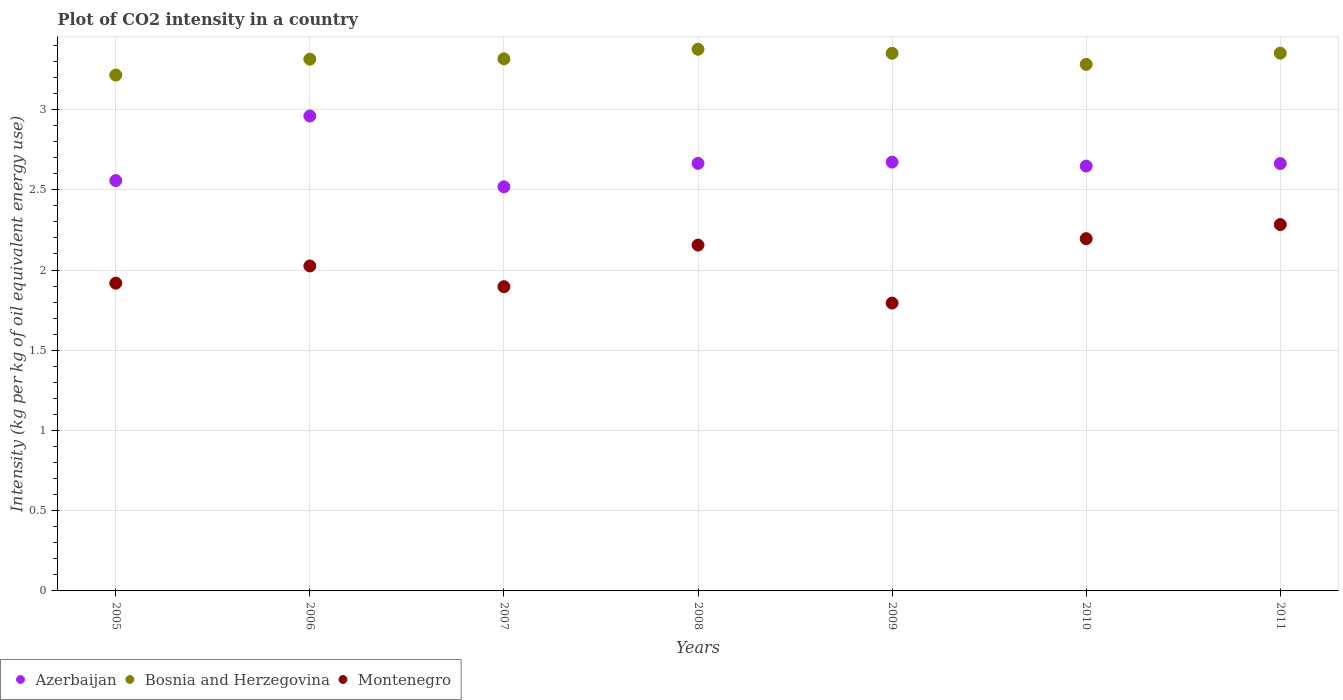Is the number of dotlines equal to the number of legend labels?
Provide a succinct answer. Yes. What is the CO2 intensity in in Montenegro in 2010?
Give a very brief answer. 2.2. Across all years, what is the maximum CO2 intensity in in Bosnia and Herzegovina?
Offer a terse response. 3.38. Across all years, what is the minimum CO2 intensity in in Montenegro?
Make the answer very short. 1.79. What is the total CO2 intensity in in Montenegro in the graph?
Provide a succinct answer. 14.27. What is the difference between the CO2 intensity in in Montenegro in 2006 and that in 2009?
Keep it short and to the point. 0.23. What is the difference between the CO2 intensity in in Bosnia and Herzegovina in 2006 and the CO2 intensity in in Montenegro in 2011?
Your answer should be very brief. 1.03. What is the average CO2 intensity in in Azerbaijan per year?
Keep it short and to the point. 2.67. In the year 2005, what is the difference between the CO2 intensity in in Azerbaijan and CO2 intensity in in Bosnia and Herzegovina?
Provide a succinct answer. -0.66. In how many years, is the CO2 intensity in in Montenegro greater than 2.2 kg?
Offer a very short reply. 1. What is the ratio of the CO2 intensity in in Montenegro in 2005 to that in 2007?
Keep it short and to the point. 1.01. What is the difference between the highest and the second highest CO2 intensity in in Montenegro?
Offer a terse response. 0.09. What is the difference between the highest and the lowest CO2 intensity in in Azerbaijan?
Your answer should be compact. 0.44. In how many years, is the CO2 intensity in in Montenegro greater than the average CO2 intensity in in Montenegro taken over all years?
Give a very brief answer. 3. Is it the case that in every year, the sum of the CO2 intensity in in Montenegro and CO2 intensity in in Azerbaijan  is greater than the CO2 intensity in in Bosnia and Herzegovina?
Offer a very short reply. Yes. Does the CO2 intensity in in Azerbaijan monotonically increase over the years?
Ensure brevity in your answer.  No. Does the graph contain grids?
Your answer should be compact. Yes. How many legend labels are there?
Make the answer very short. 3. What is the title of the graph?
Your answer should be very brief. Plot of CO2 intensity in a country. Does "Iceland" appear as one of the legend labels in the graph?
Your response must be concise. No. What is the label or title of the X-axis?
Offer a very short reply. Years. What is the label or title of the Y-axis?
Offer a terse response. Intensity (kg per kg of oil equivalent energy use). What is the Intensity (kg per kg of oil equivalent energy use) in Azerbaijan in 2005?
Your response must be concise. 2.56. What is the Intensity (kg per kg of oil equivalent energy use) of Bosnia and Herzegovina in 2005?
Offer a terse response. 3.22. What is the Intensity (kg per kg of oil equivalent energy use) in Montenegro in 2005?
Keep it short and to the point. 1.92. What is the Intensity (kg per kg of oil equivalent energy use) of Azerbaijan in 2006?
Your response must be concise. 2.96. What is the Intensity (kg per kg of oil equivalent energy use) in Bosnia and Herzegovina in 2006?
Offer a very short reply. 3.31. What is the Intensity (kg per kg of oil equivalent energy use) of Montenegro in 2006?
Your answer should be compact. 2.03. What is the Intensity (kg per kg of oil equivalent energy use) of Azerbaijan in 2007?
Your answer should be very brief. 2.52. What is the Intensity (kg per kg of oil equivalent energy use) of Bosnia and Herzegovina in 2007?
Give a very brief answer. 3.32. What is the Intensity (kg per kg of oil equivalent energy use) in Montenegro in 2007?
Provide a short and direct response. 1.9. What is the Intensity (kg per kg of oil equivalent energy use) in Azerbaijan in 2008?
Your response must be concise. 2.66. What is the Intensity (kg per kg of oil equivalent energy use) in Bosnia and Herzegovina in 2008?
Keep it short and to the point. 3.38. What is the Intensity (kg per kg of oil equivalent energy use) in Montenegro in 2008?
Ensure brevity in your answer.  2.16. What is the Intensity (kg per kg of oil equivalent energy use) of Azerbaijan in 2009?
Offer a very short reply. 2.67. What is the Intensity (kg per kg of oil equivalent energy use) of Bosnia and Herzegovina in 2009?
Provide a succinct answer. 3.35. What is the Intensity (kg per kg of oil equivalent energy use) in Montenegro in 2009?
Provide a succinct answer. 1.79. What is the Intensity (kg per kg of oil equivalent energy use) of Azerbaijan in 2010?
Offer a very short reply. 2.65. What is the Intensity (kg per kg of oil equivalent energy use) in Bosnia and Herzegovina in 2010?
Your response must be concise. 3.28. What is the Intensity (kg per kg of oil equivalent energy use) of Montenegro in 2010?
Give a very brief answer. 2.2. What is the Intensity (kg per kg of oil equivalent energy use) in Azerbaijan in 2011?
Ensure brevity in your answer.  2.66. What is the Intensity (kg per kg of oil equivalent energy use) of Bosnia and Herzegovina in 2011?
Provide a succinct answer. 3.35. What is the Intensity (kg per kg of oil equivalent energy use) in Montenegro in 2011?
Provide a succinct answer. 2.28. Across all years, what is the maximum Intensity (kg per kg of oil equivalent energy use) of Azerbaijan?
Your response must be concise. 2.96. Across all years, what is the maximum Intensity (kg per kg of oil equivalent energy use) in Bosnia and Herzegovina?
Offer a terse response. 3.38. Across all years, what is the maximum Intensity (kg per kg of oil equivalent energy use) in Montenegro?
Your response must be concise. 2.28. Across all years, what is the minimum Intensity (kg per kg of oil equivalent energy use) of Azerbaijan?
Give a very brief answer. 2.52. Across all years, what is the minimum Intensity (kg per kg of oil equivalent energy use) of Bosnia and Herzegovina?
Ensure brevity in your answer.  3.22. Across all years, what is the minimum Intensity (kg per kg of oil equivalent energy use) of Montenegro?
Ensure brevity in your answer.  1.79. What is the total Intensity (kg per kg of oil equivalent energy use) in Azerbaijan in the graph?
Provide a short and direct response. 18.69. What is the total Intensity (kg per kg of oil equivalent energy use) in Bosnia and Herzegovina in the graph?
Keep it short and to the point. 23.21. What is the total Intensity (kg per kg of oil equivalent energy use) in Montenegro in the graph?
Offer a very short reply. 14.27. What is the difference between the Intensity (kg per kg of oil equivalent energy use) of Azerbaijan in 2005 and that in 2006?
Ensure brevity in your answer.  -0.4. What is the difference between the Intensity (kg per kg of oil equivalent energy use) in Bosnia and Herzegovina in 2005 and that in 2006?
Provide a short and direct response. -0.1. What is the difference between the Intensity (kg per kg of oil equivalent energy use) in Montenegro in 2005 and that in 2006?
Make the answer very short. -0.11. What is the difference between the Intensity (kg per kg of oil equivalent energy use) of Azerbaijan in 2005 and that in 2007?
Your answer should be compact. 0.04. What is the difference between the Intensity (kg per kg of oil equivalent energy use) of Bosnia and Herzegovina in 2005 and that in 2007?
Provide a succinct answer. -0.1. What is the difference between the Intensity (kg per kg of oil equivalent energy use) in Montenegro in 2005 and that in 2007?
Offer a very short reply. 0.02. What is the difference between the Intensity (kg per kg of oil equivalent energy use) of Azerbaijan in 2005 and that in 2008?
Your response must be concise. -0.11. What is the difference between the Intensity (kg per kg of oil equivalent energy use) of Bosnia and Herzegovina in 2005 and that in 2008?
Keep it short and to the point. -0.16. What is the difference between the Intensity (kg per kg of oil equivalent energy use) of Montenegro in 2005 and that in 2008?
Offer a very short reply. -0.24. What is the difference between the Intensity (kg per kg of oil equivalent energy use) in Azerbaijan in 2005 and that in 2009?
Provide a succinct answer. -0.12. What is the difference between the Intensity (kg per kg of oil equivalent energy use) of Bosnia and Herzegovina in 2005 and that in 2009?
Offer a very short reply. -0.14. What is the difference between the Intensity (kg per kg of oil equivalent energy use) in Montenegro in 2005 and that in 2009?
Ensure brevity in your answer.  0.12. What is the difference between the Intensity (kg per kg of oil equivalent energy use) of Azerbaijan in 2005 and that in 2010?
Ensure brevity in your answer.  -0.09. What is the difference between the Intensity (kg per kg of oil equivalent energy use) of Bosnia and Herzegovina in 2005 and that in 2010?
Offer a very short reply. -0.07. What is the difference between the Intensity (kg per kg of oil equivalent energy use) of Montenegro in 2005 and that in 2010?
Give a very brief answer. -0.28. What is the difference between the Intensity (kg per kg of oil equivalent energy use) of Azerbaijan in 2005 and that in 2011?
Keep it short and to the point. -0.11. What is the difference between the Intensity (kg per kg of oil equivalent energy use) of Bosnia and Herzegovina in 2005 and that in 2011?
Keep it short and to the point. -0.14. What is the difference between the Intensity (kg per kg of oil equivalent energy use) in Montenegro in 2005 and that in 2011?
Provide a short and direct response. -0.37. What is the difference between the Intensity (kg per kg of oil equivalent energy use) in Azerbaijan in 2006 and that in 2007?
Ensure brevity in your answer.  0.44. What is the difference between the Intensity (kg per kg of oil equivalent energy use) in Bosnia and Herzegovina in 2006 and that in 2007?
Provide a short and direct response. -0. What is the difference between the Intensity (kg per kg of oil equivalent energy use) in Montenegro in 2006 and that in 2007?
Your answer should be compact. 0.13. What is the difference between the Intensity (kg per kg of oil equivalent energy use) in Azerbaijan in 2006 and that in 2008?
Your response must be concise. 0.3. What is the difference between the Intensity (kg per kg of oil equivalent energy use) of Bosnia and Herzegovina in 2006 and that in 2008?
Your answer should be very brief. -0.06. What is the difference between the Intensity (kg per kg of oil equivalent energy use) of Montenegro in 2006 and that in 2008?
Your answer should be very brief. -0.13. What is the difference between the Intensity (kg per kg of oil equivalent energy use) in Azerbaijan in 2006 and that in 2009?
Your answer should be compact. 0.29. What is the difference between the Intensity (kg per kg of oil equivalent energy use) in Bosnia and Herzegovina in 2006 and that in 2009?
Offer a very short reply. -0.04. What is the difference between the Intensity (kg per kg of oil equivalent energy use) of Montenegro in 2006 and that in 2009?
Give a very brief answer. 0.23. What is the difference between the Intensity (kg per kg of oil equivalent energy use) in Azerbaijan in 2006 and that in 2010?
Keep it short and to the point. 0.31. What is the difference between the Intensity (kg per kg of oil equivalent energy use) in Bosnia and Herzegovina in 2006 and that in 2010?
Make the answer very short. 0.03. What is the difference between the Intensity (kg per kg of oil equivalent energy use) of Montenegro in 2006 and that in 2010?
Provide a succinct answer. -0.17. What is the difference between the Intensity (kg per kg of oil equivalent energy use) of Azerbaijan in 2006 and that in 2011?
Your answer should be very brief. 0.3. What is the difference between the Intensity (kg per kg of oil equivalent energy use) of Bosnia and Herzegovina in 2006 and that in 2011?
Give a very brief answer. -0.04. What is the difference between the Intensity (kg per kg of oil equivalent energy use) of Montenegro in 2006 and that in 2011?
Make the answer very short. -0.26. What is the difference between the Intensity (kg per kg of oil equivalent energy use) of Azerbaijan in 2007 and that in 2008?
Your response must be concise. -0.15. What is the difference between the Intensity (kg per kg of oil equivalent energy use) of Bosnia and Herzegovina in 2007 and that in 2008?
Offer a very short reply. -0.06. What is the difference between the Intensity (kg per kg of oil equivalent energy use) of Montenegro in 2007 and that in 2008?
Your response must be concise. -0.26. What is the difference between the Intensity (kg per kg of oil equivalent energy use) of Azerbaijan in 2007 and that in 2009?
Offer a terse response. -0.15. What is the difference between the Intensity (kg per kg of oil equivalent energy use) in Bosnia and Herzegovina in 2007 and that in 2009?
Provide a short and direct response. -0.03. What is the difference between the Intensity (kg per kg of oil equivalent energy use) of Montenegro in 2007 and that in 2009?
Provide a succinct answer. 0.1. What is the difference between the Intensity (kg per kg of oil equivalent energy use) in Azerbaijan in 2007 and that in 2010?
Offer a terse response. -0.13. What is the difference between the Intensity (kg per kg of oil equivalent energy use) in Bosnia and Herzegovina in 2007 and that in 2010?
Your answer should be compact. 0.03. What is the difference between the Intensity (kg per kg of oil equivalent energy use) in Montenegro in 2007 and that in 2010?
Provide a succinct answer. -0.3. What is the difference between the Intensity (kg per kg of oil equivalent energy use) in Azerbaijan in 2007 and that in 2011?
Make the answer very short. -0.14. What is the difference between the Intensity (kg per kg of oil equivalent energy use) in Bosnia and Herzegovina in 2007 and that in 2011?
Ensure brevity in your answer.  -0.04. What is the difference between the Intensity (kg per kg of oil equivalent energy use) of Montenegro in 2007 and that in 2011?
Offer a very short reply. -0.39. What is the difference between the Intensity (kg per kg of oil equivalent energy use) in Azerbaijan in 2008 and that in 2009?
Offer a terse response. -0.01. What is the difference between the Intensity (kg per kg of oil equivalent energy use) of Bosnia and Herzegovina in 2008 and that in 2009?
Keep it short and to the point. 0.03. What is the difference between the Intensity (kg per kg of oil equivalent energy use) in Montenegro in 2008 and that in 2009?
Provide a succinct answer. 0.36. What is the difference between the Intensity (kg per kg of oil equivalent energy use) of Azerbaijan in 2008 and that in 2010?
Provide a short and direct response. 0.02. What is the difference between the Intensity (kg per kg of oil equivalent energy use) in Bosnia and Herzegovina in 2008 and that in 2010?
Keep it short and to the point. 0.09. What is the difference between the Intensity (kg per kg of oil equivalent energy use) in Montenegro in 2008 and that in 2010?
Your response must be concise. -0.04. What is the difference between the Intensity (kg per kg of oil equivalent energy use) in Azerbaijan in 2008 and that in 2011?
Provide a succinct answer. 0. What is the difference between the Intensity (kg per kg of oil equivalent energy use) in Bosnia and Herzegovina in 2008 and that in 2011?
Provide a short and direct response. 0.02. What is the difference between the Intensity (kg per kg of oil equivalent energy use) of Montenegro in 2008 and that in 2011?
Your answer should be compact. -0.13. What is the difference between the Intensity (kg per kg of oil equivalent energy use) of Azerbaijan in 2009 and that in 2010?
Offer a very short reply. 0.02. What is the difference between the Intensity (kg per kg of oil equivalent energy use) in Bosnia and Herzegovina in 2009 and that in 2010?
Keep it short and to the point. 0.07. What is the difference between the Intensity (kg per kg of oil equivalent energy use) of Montenegro in 2009 and that in 2010?
Your answer should be very brief. -0.4. What is the difference between the Intensity (kg per kg of oil equivalent energy use) in Azerbaijan in 2009 and that in 2011?
Your response must be concise. 0.01. What is the difference between the Intensity (kg per kg of oil equivalent energy use) of Bosnia and Herzegovina in 2009 and that in 2011?
Provide a short and direct response. -0. What is the difference between the Intensity (kg per kg of oil equivalent energy use) of Montenegro in 2009 and that in 2011?
Your answer should be very brief. -0.49. What is the difference between the Intensity (kg per kg of oil equivalent energy use) of Azerbaijan in 2010 and that in 2011?
Your answer should be very brief. -0.02. What is the difference between the Intensity (kg per kg of oil equivalent energy use) in Bosnia and Herzegovina in 2010 and that in 2011?
Keep it short and to the point. -0.07. What is the difference between the Intensity (kg per kg of oil equivalent energy use) of Montenegro in 2010 and that in 2011?
Keep it short and to the point. -0.09. What is the difference between the Intensity (kg per kg of oil equivalent energy use) in Azerbaijan in 2005 and the Intensity (kg per kg of oil equivalent energy use) in Bosnia and Herzegovina in 2006?
Provide a succinct answer. -0.76. What is the difference between the Intensity (kg per kg of oil equivalent energy use) of Azerbaijan in 2005 and the Intensity (kg per kg of oil equivalent energy use) of Montenegro in 2006?
Make the answer very short. 0.53. What is the difference between the Intensity (kg per kg of oil equivalent energy use) of Bosnia and Herzegovina in 2005 and the Intensity (kg per kg of oil equivalent energy use) of Montenegro in 2006?
Provide a short and direct response. 1.19. What is the difference between the Intensity (kg per kg of oil equivalent energy use) in Azerbaijan in 2005 and the Intensity (kg per kg of oil equivalent energy use) in Bosnia and Herzegovina in 2007?
Make the answer very short. -0.76. What is the difference between the Intensity (kg per kg of oil equivalent energy use) in Azerbaijan in 2005 and the Intensity (kg per kg of oil equivalent energy use) in Montenegro in 2007?
Your response must be concise. 0.66. What is the difference between the Intensity (kg per kg of oil equivalent energy use) in Bosnia and Herzegovina in 2005 and the Intensity (kg per kg of oil equivalent energy use) in Montenegro in 2007?
Provide a short and direct response. 1.32. What is the difference between the Intensity (kg per kg of oil equivalent energy use) of Azerbaijan in 2005 and the Intensity (kg per kg of oil equivalent energy use) of Bosnia and Herzegovina in 2008?
Provide a short and direct response. -0.82. What is the difference between the Intensity (kg per kg of oil equivalent energy use) in Azerbaijan in 2005 and the Intensity (kg per kg of oil equivalent energy use) in Montenegro in 2008?
Give a very brief answer. 0.4. What is the difference between the Intensity (kg per kg of oil equivalent energy use) in Bosnia and Herzegovina in 2005 and the Intensity (kg per kg of oil equivalent energy use) in Montenegro in 2008?
Make the answer very short. 1.06. What is the difference between the Intensity (kg per kg of oil equivalent energy use) in Azerbaijan in 2005 and the Intensity (kg per kg of oil equivalent energy use) in Bosnia and Herzegovina in 2009?
Your answer should be compact. -0.79. What is the difference between the Intensity (kg per kg of oil equivalent energy use) of Azerbaijan in 2005 and the Intensity (kg per kg of oil equivalent energy use) of Montenegro in 2009?
Give a very brief answer. 0.76. What is the difference between the Intensity (kg per kg of oil equivalent energy use) in Bosnia and Herzegovina in 2005 and the Intensity (kg per kg of oil equivalent energy use) in Montenegro in 2009?
Provide a short and direct response. 1.42. What is the difference between the Intensity (kg per kg of oil equivalent energy use) in Azerbaijan in 2005 and the Intensity (kg per kg of oil equivalent energy use) in Bosnia and Herzegovina in 2010?
Provide a succinct answer. -0.72. What is the difference between the Intensity (kg per kg of oil equivalent energy use) in Azerbaijan in 2005 and the Intensity (kg per kg of oil equivalent energy use) in Montenegro in 2010?
Your answer should be very brief. 0.36. What is the difference between the Intensity (kg per kg of oil equivalent energy use) of Bosnia and Herzegovina in 2005 and the Intensity (kg per kg of oil equivalent energy use) of Montenegro in 2010?
Ensure brevity in your answer.  1.02. What is the difference between the Intensity (kg per kg of oil equivalent energy use) of Azerbaijan in 2005 and the Intensity (kg per kg of oil equivalent energy use) of Bosnia and Herzegovina in 2011?
Your response must be concise. -0.79. What is the difference between the Intensity (kg per kg of oil equivalent energy use) of Azerbaijan in 2005 and the Intensity (kg per kg of oil equivalent energy use) of Montenegro in 2011?
Make the answer very short. 0.27. What is the difference between the Intensity (kg per kg of oil equivalent energy use) in Bosnia and Herzegovina in 2005 and the Intensity (kg per kg of oil equivalent energy use) in Montenegro in 2011?
Your response must be concise. 0.93. What is the difference between the Intensity (kg per kg of oil equivalent energy use) in Azerbaijan in 2006 and the Intensity (kg per kg of oil equivalent energy use) in Bosnia and Herzegovina in 2007?
Ensure brevity in your answer.  -0.36. What is the difference between the Intensity (kg per kg of oil equivalent energy use) of Azerbaijan in 2006 and the Intensity (kg per kg of oil equivalent energy use) of Montenegro in 2007?
Ensure brevity in your answer.  1.06. What is the difference between the Intensity (kg per kg of oil equivalent energy use) in Bosnia and Herzegovina in 2006 and the Intensity (kg per kg of oil equivalent energy use) in Montenegro in 2007?
Keep it short and to the point. 1.42. What is the difference between the Intensity (kg per kg of oil equivalent energy use) in Azerbaijan in 2006 and the Intensity (kg per kg of oil equivalent energy use) in Bosnia and Herzegovina in 2008?
Your answer should be very brief. -0.42. What is the difference between the Intensity (kg per kg of oil equivalent energy use) of Azerbaijan in 2006 and the Intensity (kg per kg of oil equivalent energy use) of Montenegro in 2008?
Give a very brief answer. 0.8. What is the difference between the Intensity (kg per kg of oil equivalent energy use) in Bosnia and Herzegovina in 2006 and the Intensity (kg per kg of oil equivalent energy use) in Montenegro in 2008?
Your answer should be compact. 1.16. What is the difference between the Intensity (kg per kg of oil equivalent energy use) in Azerbaijan in 2006 and the Intensity (kg per kg of oil equivalent energy use) in Bosnia and Herzegovina in 2009?
Your answer should be compact. -0.39. What is the difference between the Intensity (kg per kg of oil equivalent energy use) in Azerbaijan in 2006 and the Intensity (kg per kg of oil equivalent energy use) in Montenegro in 2009?
Offer a very short reply. 1.17. What is the difference between the Intensity (kg per kg of oil equivalent energy use) in Bosnia and Herzegovina in 2006 and the Intensity (kg per kg of oil equivalent energy use) in Montenegro in 2009?
Your answer should be very brief. 1.52. What is the difference between the Intensity (kg per kg of oil equivalent energy use) of Azerbaijan in 2006 and the Intensity (kg per kg of oil equivalent energy use) of Bosnia and Herzegovina in 2010?
Your response must be concise. -0.32. What is the difference between the Intensity (kg per kg of oil equivalent energy use) in Azerbaijan in 2006 and the Intensity (kg per kg of oil equivalent energy use) in Montenegro in 2010?
Your answer should be very brief. 0.76. What is the difference between the Intensity (kg per kg of oil equivalent energy use) of Bosnia and Herzegovina in 2006 and the Intensity (kg per kg of oil equivalent energy use) of Montenegro in 2010?
Keep it short and to the point. 1.12. What is the difference between the Intensity (kg per kg of oil equivalent energy use) in Azerbaijan in 2006 and the Intensity (kg per kg of oil equivalent energy use) in Bosnia and Herzegovina in 2011?
Give a very brief answer. -0.39. What is the difference between the Intensity (kg per kg of oil equivalent energy use) of Azerbaijan in 2006 and the Intensity (kg per kg of oil equivalent energy use) of Montenegro in 2011?
Give a very brief answer. 0.68. What is the difference between the Intensity (kg per kg of oil equivalent energy use) of Bosnia and Herzegovina in 2006 and the Intensity (kg per kg of oil equivalent energy use) of Montenegro in 2011?
Make the answer very short. 1.03. What is the difference between the Intensity (kg per kg of oil equivalent energy use) in Azerbaijan in 2007 and the Intensity (kg per kg of oil equivalent energy use) in Bosnia and Herzegovina in 2008?
Your answer should be very brief. -0.86. What is the difference between the Intensity (kg per kg of oil equivalent energy use) of Azerbaijan in 2007 and the Intensity (kg per kg of oil equivalent energy use) of Montenegro in 2008?
Your answer should be very brief. 0.36. What is the difference between the Intensity (kg per kg of oil equivalent energy use) in Bosnia and Herzegovina in 2007 and the Intensity (kg per kg of oil equivalent energy use) in Montenegro in 2008?
Your response must be concise. 1.16. What is the difference between the Intensity (kg per kg of oil equivalent energy use) of Azerbaijan in 2007 and the Intensity (kg per kg of oil equivalent energy use) of Bosnia and Herzegovina in 2009?
Offer a terse response. -0.83. What is the difference between the Intensity (kg per kg of oil equivalent energy use) of Azerbaijan in 2007 and the Intensity (kg per kg of oil equivalent energy use) of Montenegro in 2009?
Your response must be concise. 0.72. What is the difference between the Intensity (kg per kg of oil equivalent energy use) of Bosnia and Herzegovina in 2007 and the Intensity (kg per kg of oil equivalent energy use) of Montenegro in 2009?
Ensure brevity in your answer.  1.52. What is the difference between the Intensity (kg per kg of oil equivalent energy use) in Azerbaijan in 2007 and the Intensity (kg per kg of oil equivalent energy use) in Bosnia and Herzegovina in 2010?
Provide a succinct answer. -0.76. What is the difference between the Intensity (kg per kg of oil equivalent energy use) in Azerbaijan in 2007 and the Intensity (kg per kg of oil equivalent energy use) in Montenegro in 2010?
Your answer should be very brief. 0.32. What is the difference between the Intensity (kg per kg of oil equivalent energy use) of Bosnia and Herzegovina in 2007 and the Intensity (kg per kg of oil equivalent energy use) of Montenegro in 2010?
Your answer should be very brief. 1.12. What is the difference between the Intensity (kg per kg of oil equivalent energy use) in Azerbaijan in 2007 and the Intensity (kg per kg of oil equivalent energy use) in Bosnia and Herzegovina in 2011?
Provide a short and direct response. -0.83. What is the difference between the Intensity (kg per kg of oil equivalent energy use) in Azerbaijan in 2007 and the Intensity (kg per kg of oil equivalent energy use) in Montenegro in 2011?
Your response must be concise. 0.24. What is the difference between the Intensity (kg per kg of oil equivalent energy use) in Bosnia and Herzegovina in 2007 and the Intensity (kg per kg of oil equivalent energy use) in Montenegro in 2011?
Offer a terse response. 1.03. What is the difference between the Intensity (kg per kg of oil equivalent energy use) in Azerbaijan in 2008 and the Intensity (kg per kg of oil equivalent energy use) in Bosnia and Herzegovina in 2009?
Your answer should be very brief. -0.69. What is the difference between the Intensity (kg per kg of oil equivalent energy use) in Azerbaijan in 2008 and the Intensity (kg per kg of oil equivalent energy use) in Montenegro in 2009?
Your response must be concise. 0.87. What is the difference between the Intensity (kg per kg of oil equivalent energy use) of Bosnia and Herzegovina in 2008 and the Intensity (kg per kg of oil equivalent energy use) of Montenegro in 2009?
Provide a succinct answer. 1.58. What is the difference between the Intensity (kg per kg of oil equivalent energy use) of Azerbaijan in 2008 and the Intensity (kg per kg of oil equivalent energy use) of Bosnia and Herzegovina in 2010?
Your response must be concise. -0.62. What is the difference between the Intensity (kg per kg of oil equivalent energy use) of Azerbaijan in 2008 and the Intensity (kg per kg of oil equivalent energy use) of Montenegro in 2010?
Provide a short and direct response. 0.47. What is the difference between the Intensity (kg per kg of oil equivalent energy use) in Bosnia and Herzegovina in 2008 and the Intensity (kg per kg of oil equivalent energy use) in Montenegro in 2010?
Provide a short and direct response. 1.18. What is the difference between the Intensity (kg per kg of oil equivalent energy use) of Azerbaijan in 2008 and the Intensity (kg per kg of oil equivalent energy use) of Bosnia and Herzegovina in 2011?
Ensure brevity in your answer.  -0.69. What is the difference between the Intensity (kg per kg of oil equivalent energy use) of Azerbaijan in 2008 and the Intensity (kg per kg of oil equivalent energy use) of Montenegro in 2011?
Provide a short and direct response. 0.38. What is the difference between the Intensity (kg per kg of oil equivalent energy use) of Bosnia and Herzegovina in 2008 and the Intensity (kg per kg of oil equivalent energy use) of Montenegro in 2011?
Keep it short and to the point. 1.09. What is the difference between the Intensity (kg per kg of oil equivalent energy use) of Azerbaijan in 2009 and the Intensity (kg per kg of oil equivalent energy use) of Bosnia and Herzegovina in 2010?
Your answer should be compact. -0.61. What is the difference between the Intensity (kg per kg of oil equivalent energy use) in Azerbaijan in 2009 and the Intensity (kg per kg of oil equivalent energy use) in Montenegro in 2010?
Keep it short and to the point. 0.48. What is the difference between the Intensity (kg per kg of oil equivalent energy use) in Bosnia and Herzegovina in 2009 and the Intensity (kg per kg of oil equivalent energy use) in Montenegro in 2010?
Provide a succinct answer. 1.16. What is the difference between the Intensity (kg per kg of oil equivalent energy use) in Azerbaijan in 2009 and the Intensity (kg per kg of oil equivalent energy use) in Bosnia and Herzegovina in 2011?
Provide a short and direct response. -0.68. What is the difference between the Intensity (kg per kg of oil equivalent energy use) of Azerbaijan in 2009 and the Intensity (kg per kg of oil equivalent energy use) of Montenegro in 2011?
Provide a succinct answer. 0.39. What is the difference between the Intensity (kg per kg of oil equivalent energy use) of Bosnia and Herzegovina in 2009 and the Intensity (kg per kg of oil equivalent energy use) of Montenegro in 2011?
Provide a short and direct response. 1.07. What is the difference between the Intensity (kg per kg of oil equivalent energy use) in Azerbaijan in 2010 and the Intensity (kg per kg of oil equivalent energy use) in Bosnia and Herzegovina in 2011?
Provide a short and direct response. -0.7. What is the difference between the Intensity (kg per kg of oil equivalent energy use) in Azerbaijan in 2010 and the Intensity (kg per kg of oil equivalent energy use) in Montenegro in 2011?
Your answer should be compact. 0.36. What is the average Intensity (kg per kg of oil equivalent energy use) of Azerbaijan per year?
Your answer should be very brief. 2.67. What is the average Intensity (kg per kg of oil equivalent energy use) in Bosnia and Herzegovina per year?
Keep it short and to the point. 3.32. What is the average Intensity (kg per kg of oil equivalent energy use) of Montenegro per year?
Offer a very short reply. 2.04. In the year 2005, what is the difference between the Intensity (kg per kg of oil equivalent energy use) of Azerbaijan and Intensity (kg per kg of oil equivalent energy use) of Bosnia and Herzegovina?
Offer a terse response. -0.66. In the year 2005, what is the difference between the Intensity (kg per kg of oil equivalent energy use) of Azerbaijan and Intensity (kg per kg of oil equivalent energy use) of Montenegro?
Your answer should be very brief. 0.64. In the year 2005, what is the difference between the Intensity (kg per kg of oil equivalent energy use) in Bosnia and Herzegovina and Intensity (kg per kg of oil equivalent energy use) in Montenegro?
Ensure brevity in your answer.  1.3. In the year 2006, what is the difference between the Intensity (kg per kg of oil equivalent energy use) in Azerbaijan and Intensity (kg per kg of oil equivalent energy use) in Bosnia and Herzegovina?
Your answer should be very brief. -0.35. In the year 2006, what is the difference between the Intensity (kg per kg of oil equivalent energy use) of Azerbaijan and Intensity (kg per kg of oil equivalent energy use) of Montenegro?
Give a very brief answer. 0.93. In the year 2006, what is the difference between the Intensity (kg per kg of oil equivalent energy use) of Bosnia and Herzegovina and Intensity (kg per kg of oil equivalent energy use) of Montenegro?
Keep it short and to the point. 1.29. In the year 2007, what is the difference between the Intensity (kg per kg of oil equivalent energy use) of Azerbaijan and Intensity (kg per kg of oil equivalent energy use) of Bosnia and Herzegovina?
Make the answer very short. -0.8. In the year 2007, what is the difference between the Intensity (kg per kg of oil equivalent energy use) of Azerbaijan and Intensity (kg per kg of oil equivalent energy use) of Montenegro?
Ensure brevity in your answer.  0.62. In the year 2007, what is the difference between the Intensity (kg per kg of oil equivalent energy use) of Bosnia and Herzegovina and Intensity (kg per kg of oil equivalent energy use) of Montenegro?
Provide a short and direct response. 1.42. In the year 2008, what is the difference between the Intensity (kg per kg of oil equivalent energy use) in Azerbaijan and Intensity (kg per kg of oil equivalent energy use) in Bosnia and Herzegovina?
Offer a very short reply. -0.71. In the year 2008, what is the difference between the Intensity (kg per kg of oil equivalent energy use) in Azerbaijan and Intensity (kg per kg of oil equivalent energy use) in Montenegro?
Keep it short and to the point. 0.51. In the year 2008, what is the difference between the Intensity (kg per kg of oil equivalent energy use) in Bosnia and Herzegovina and Intensity (kg per kg of oil equivalent energy use) in Montenegro?
Your response must be concise. 1.22. In the year 2009, what is the difference between the Intensity (kg per kg of oil equivalent energy use) of Azerbaijan and Intensity (kg per kg of oil equivalent energy use) of Bosnia and Herzegovina?
Offer a very short reply. -0.68. In the year 2009, what is the difference between the Intensity (kg per kg of oil equivalent energy use) in Azerbaijan and Intensity (kg per kg of oil equivalent energy use) in Montenegro?
Ensure brevity in your answer.  0.88. In the year 2009, what is the difference between the Intensity (kg per kg of oil equivalent energy use) of Bosnia and Herzegovina and Intensity (kg per kg of oil equivalent energy use) of Montenegro?
Give a very brief answer. 1.56. In the year 2010, what is the difference between the Intensity (kg per kg of oil equivalent energy use) of Azerbaijan and Intensity (kg per kg of oil equivalent energy use) of Bosnia and Herzegovina?
Offer a terse response. -0.63. In the year 2010, what is the difference between the Intensity (kg per kg of oil equivalent energy use) of Azerbaijan and Intensity (kg per kg of oil equivalent energy use) of Montenegro?
Provide a short and direct response. 0.45. In the year 2010, what is the difference between the Intensity (kg per kg of oil equivalent energy use) of Bosnia and Herzegovina and Intensity (kg per kg of oil equivalent energy use) of Montenegro?
Keep it short and to the point. 1.09. In the year 2011, what is the difference between the Intensity (kg per kg of oil equivalent energy use) in Azerbaijan and Intensity (kg per kg of oil equivalent energy use) in Bosnia and Herzegovina?
Provide a short and direct response. -0.69. In the year 2011, what is the difference between the Intensity (kg per kg of oil equivalent energy use) in Azerbaijan and Intensity (kg per kg of oil equivalent energy use) in Montenegro?
Ensure brevity in your answer.  0.38. In the year 2011, what is the difference between the Intensity (kg per kg of oil equivalent energy use) of Bosnia and Herzegovina and Intensity (kg per kg of oil equivalent energy use) of Montenegro?
Your answer should be compact. 1.07. What is the ratio of the Intensity (kg per kg of oil equivalent energy use) in Azerbaijan in 2005 to that in 2006?
Your response must be concise. 0.86. What is the ratio of the Intensity (kg per kg of oil equivalent energy use) in Bosnia and Herzegovina in 2005 to that in 2006?
Provide a succinct answer. 0.97. What is the ratio of the Intensity (kg per kg of oil equivalent energy use) of Montenegro in 2005 to that in 2006?
Provide a short and direct response. 0.95. What is the ratio of the Intensity (kg per kg of oil equivalent energy use) in Azerbaijan in 2005 to that in 2007?
Ensure brevity in your answer.  1.02. What is the ratio of the Intensity (kg per kg of oil equivalent energy use) of Bosnia and Herzegovina in 2005 to that in 2007?
Offer a terse response. 0.97. What is the ratio of the Intensity (kg per kg of oil equivalent energy use) in Montenegro in 2005 to that in 2007?
Make the answer very short. 1.01. What is the ratio of the Intensity (kg per kg of oil equivalent energy use) in Azerbaijan in 2005 to that in 2008?
Your answer should be compact. 0.96. What is the ratio of the Intensity (kg per kg of oil equivalent energy use) in Bosnia and Herzegovina in 2005 to that in 2008?
Your answer should be compact. 0.95. What is the ratio of the Intensity (kg per kg of oil equivalent energy use) of Montenegro in 2005 to that in 2008?
Ensure brevity in your answer.  0.89. What is the ratio of the Intensity (kg per kg of oil equivalent energy use) of Azerbaijan in 2005 to that in 2009?
Give a very brief answer. 0.96. What is the ratio of the Intensity (kg per kg of oil equivalent energy use) of Bosnia and Herzegovina in 2005 to that in 2009?
Offer a very short reply. 0.96. What is the ratio of the Intensity (kg per kg of oil equivalent energy use) in Montenegro in 2005 to that in 2009?
Your response must be concise. 1.07. What is the ratio of the Intensity (kg per kg of oil equivalent energy use) in Azerbaijan in 2005 to that in 2010?
Your response must be concise. 0.97. What is the ratio of the Intensity (kg per kg of oil equivalent energy use) in Bosnia and Herzegovina in 2005 to that in 2010?
Your answer should be very brief. 0.98. What is the ratio of the Intensity (kg per kg of oil equivalent energy use) of Montenegro in 2005 to that in 2010?
Provide a succinct answer. 0.87. What is the ratio of the Intensity (kg per kg of oil equivalent energy use) of Azerbaijan in 2005 to that in 2011?
Offer a very short reply. 0.96. What is the ratio of the Intensity (kg per kg of oil equivalent energy use) in Bosnia and Herzegovina in 2005 to that in 2011?
Keep it short and to the point. 0.96. What is the ratio of the Intensity (kg per kg of oil equivalent energy use) of Montenegro in 2005 to that in 2011?
Make the answer very short. 0.84. What is the ratio of the Intensity (kg per kg of oil equivalent energy use) in Azerbaijan in 2006 to that in 2007?
Make the answer very short. 1.18. What is the ratio of the Intensity (kg per kg of oil equivalent energy use) in Montenegro in 2006 to that in 2007?
Your answer should be very brief. 1.07. What is the ratio of the Intensity (kg per kg of oil equivalent energy use) of Azerbaijan in 2006 to that in 2008?
Provide a succinct answer. 1.11. What is the ratio of the Intensity (kg per kg of oil equivalent energy use) of Bosnia and Herzegovina in 2006 to that in 2008?
Offer a very short reply. 0.98. What is the ratio of the Intensity (kg per kg of oil equivalent energy use) of Montenegro in 2006 to that in 2008?
Make the answer very short. 0.94. What is the ratio of the Intensity (kg per kg of oil equivalent energy use) of Azerbaijan in 2006 to that in 2009?
Make the answer very short. 1.11. What is the ratio of the Intensity (kg per kg of oil equivalent energy use) in Bosnia and Herzegovina in 2006 to that in 2009?
Make the answer very short. 0.99. What is the ratio of the Intensity (kg per kg of oil equivalent energy use) of Montenegro in 2006 to that in 2009?
Your response must be concise. 1.13. What is the ratio of the Intensity (kg per kg of oil equivalent energy use) of Azerbaijan in 2006 to that in 2010?
Ensure brevity in your answer.  1.12. What is the ratio of the Intensity (kg per kg of oil equivalent energy use) in Bosnia and Herzegovina in 2006 to that in 2010?
Provide a short and direct response. 1.01. What is the ratio of the Intensity (kg per kg of oil equivalent energy use) of Montenegro in 2006 to that in 2010?
Offer a very short reply. 0.92. What is the ratio of the Intensity (kg per kg of oil equivalent energy use) in Azerbaijan in 2006 to that in 2011?
Provide a short and direct response. 1.11. What is the ratio of the Intensity (kg per kg of oil equivalent energy use) in Montenegro in 2006 to that in 2011?
Your answer should be compact. 0.89. What is the ratio of the Intensity (kg per kg of oil equivalent energy use) of Azerbaijan in 2007 to that in 2008?
Provide a short and direct response. 0.95. What is the ratio of the Intensity (kg per kg of oil equivalent energy use) in Bosnia and Herzegovina in 2007 to that in 2008?
Provide a succinct answer. 0.98. What is the ratio of the Intensity (kg per kg of oil equivalent energy use) in Montenegro in 2007 to that in 2008?
Ensure brevity in your answer.  0.88. What is the ratio of the Intensity (kg per kg of oil equivalent energy use) of Azerbaijan in 2007 to that in 2009?
Keep it short and to the point. 0.94. What is the ratio of the Intensity (kg per kg of oil equivalent energy use) of Montenegro in 2007 to that in 2009?
Provide a succinct answer. 1.06. What is the ratio of the Intensity (kg per kg of oil equivalent energy use) of Azerbaijan in 2007 to that in 2010?
Your answer should be very brief. 0.95. What is the ratio of the Intensity (kg per kg of oil equivalent energy use) of Bosnia and Herzegovina in 2007 to that in 2010?
Ensure brevity in your answer.  1.01. What is the ratio of the Intensity (kg per kg of oil equivalent energy use) of Montenegro in 2007 to that in 2010?
Offer a terse response. 0.86. What is the ratio of the Intensity (kg per kg of oil equivalent energy use) of Azerbaijan in 2007 to that in 2011?
Your response must be concise. 0.95. What is the ratio of the Intensity (kg per kg of oil equivalent energy use) of Montenegro in 2007 to that in 2011?
Your answer should be very brief. 0.83. What is the ratio of the Intensity (kg per kg of oil equivalent energy use) in Bosnia and Herzegovina in 2008 to that in 2009?
Your answer should be very brief. 1.01. What is the ratio of the Intensity (kg per kg of oil equivalent energy use) of Montenegro in 2008 to that in 2009?
Make the answer very short. 1.2. What is the ratio of the Intensity (kg per kg of oil equivalent energy use) in Azerbaijan in 2008 to that in 2010?
Offer a very short reply. 1.01. What is the ratio of the Intensity (kg per kg of oil equivalent energy use) in Bosnia and Herzegovina in 2008 to that in 2010?
Your answer should be compact. 1.03. What is the ratio of the Intensity (kg per kg of oil equivalent energy use) of Montenegro in 2008 to that in 2010?
Your answer should be very brief. 0.98. What is the ratio of the Intensity (kg per kg of oil equivalent energy use) of Azerbaijan in 2008 to that in 2011?
Keep it short and to the point. 1. What is the ratio of the Intensity (kg per kg of oil equivalent energy use) of Bosnia and Herzegovina in 2008 to that in 2011?
Provide a short and direct response. 1.01. What is the ratio of the Intensity (kg per kg of oil equivalent energy use) of Montenegro in 2008 to that in 2011?
Make the answer very short. 0.94. What is the ratio of the Intensity (kg per kg of oil equivalent energy use) of Azerbaijan in 2009 to that in 2010?
Your response must be concise. 1.01. What is the ratio of the Intensity (kg per kg of oil equivalent energy use) in Bosnia and Herzegovina in 2009 to that in 2010?
Your answer should be very brief. 1.02. What is the ratio of the Intensity (kg per kg of oil equivalent energy use) of Montenegro in 2009 to that in 2010?
Provide a succinct answer. 0.82. What is the ratio of the Intensity (kg per kg of oil equivalent energy use) in Azerbaijan in 2009 to that in 2011?
Offer a terse response. 1. What is the ratio of the Intensity (kg per kg of oil equivalent energy use) in Bosnia and Herzegovina in 2009 to that in 2011?
Your answer should be compact. 1. What is the ratio of the Intensity (kg per kg of oil equivalent energy use) in Montenegro in 2009 to that in 2011?
Your answer should be very brief. 0.79. What is the ratio of the Intensity (kg per kg of oil equivalent energy use) in Azerbaijan in 2010 to that in 2011?
Provide a succinct answer. 0.99. What is the ratio of the Intensity (kg per kg of oil equivalent energy use) in Bosnia and Herzegovina in 2010 to that in 2011?
Keep it short and to the point. 0.98. What is the ratio of the Intensity (kg per kg of oil equivalent energy use) of Montenegro in 2010 to that in 2011?
Make the answer very short. 0.96. What is the difference between the highest and the second highest Intensity (kg per kg of oil equivalent energy use) of Azerbaijan?
Your response must be concise. 0.29. What is the difference between the highest and the second highest Intensity (kg per kg of oil equivalent energy use) in Bosnia and Herzegovina?
Give a very brief answer. 0.02. What is the difference between the highest and the second highest Intensity (kg per kg of oil equivalent energy use) of Montenegro?
Your response must be concise. 0.09. What is the difference between the highest and the lowest Intensity (kg per kg of oil equivalent energy use) of Azerbaijan?
Offer a very short reply. 0.44. What is the difference between the highest and the lowest Intensity (kg per kg of oil equivalent energy use) in Bosnia and Herzegovina?
Provide a short and direct response. 0.16. What is the difference between the highest and the lowest Intensity (kg per kg of oil equivalent energy use) of Montenegro?
Offer a very short reply. 0.49. 